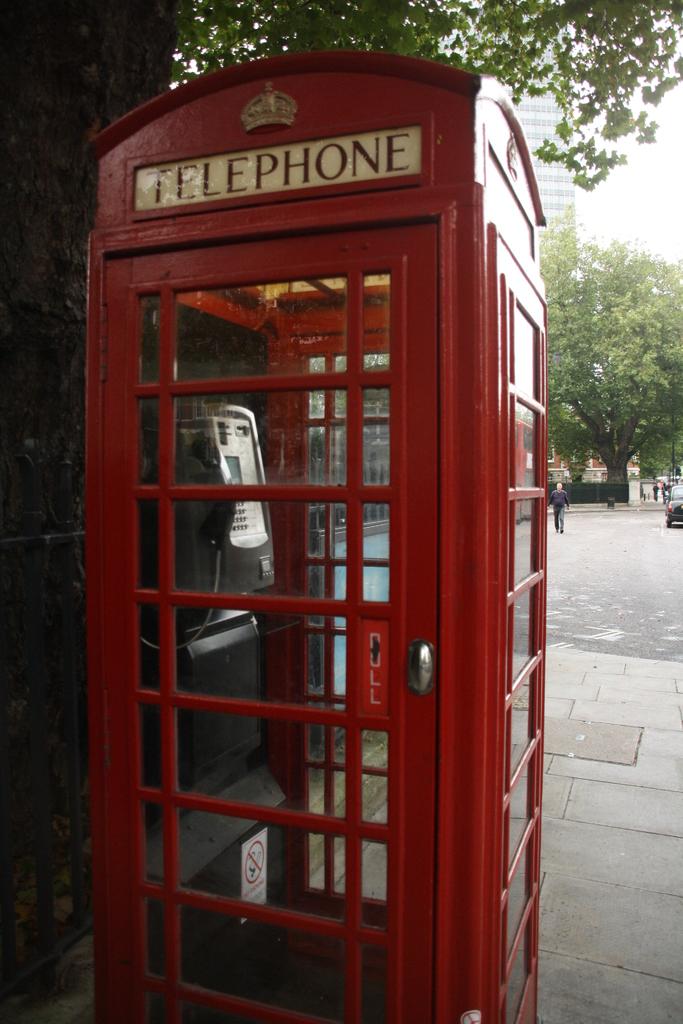What kind of both is this?
Give a very brief answer. Telephone. Does this telephone booth have a push or pull door?
Keep it short and to the point. Pull. 